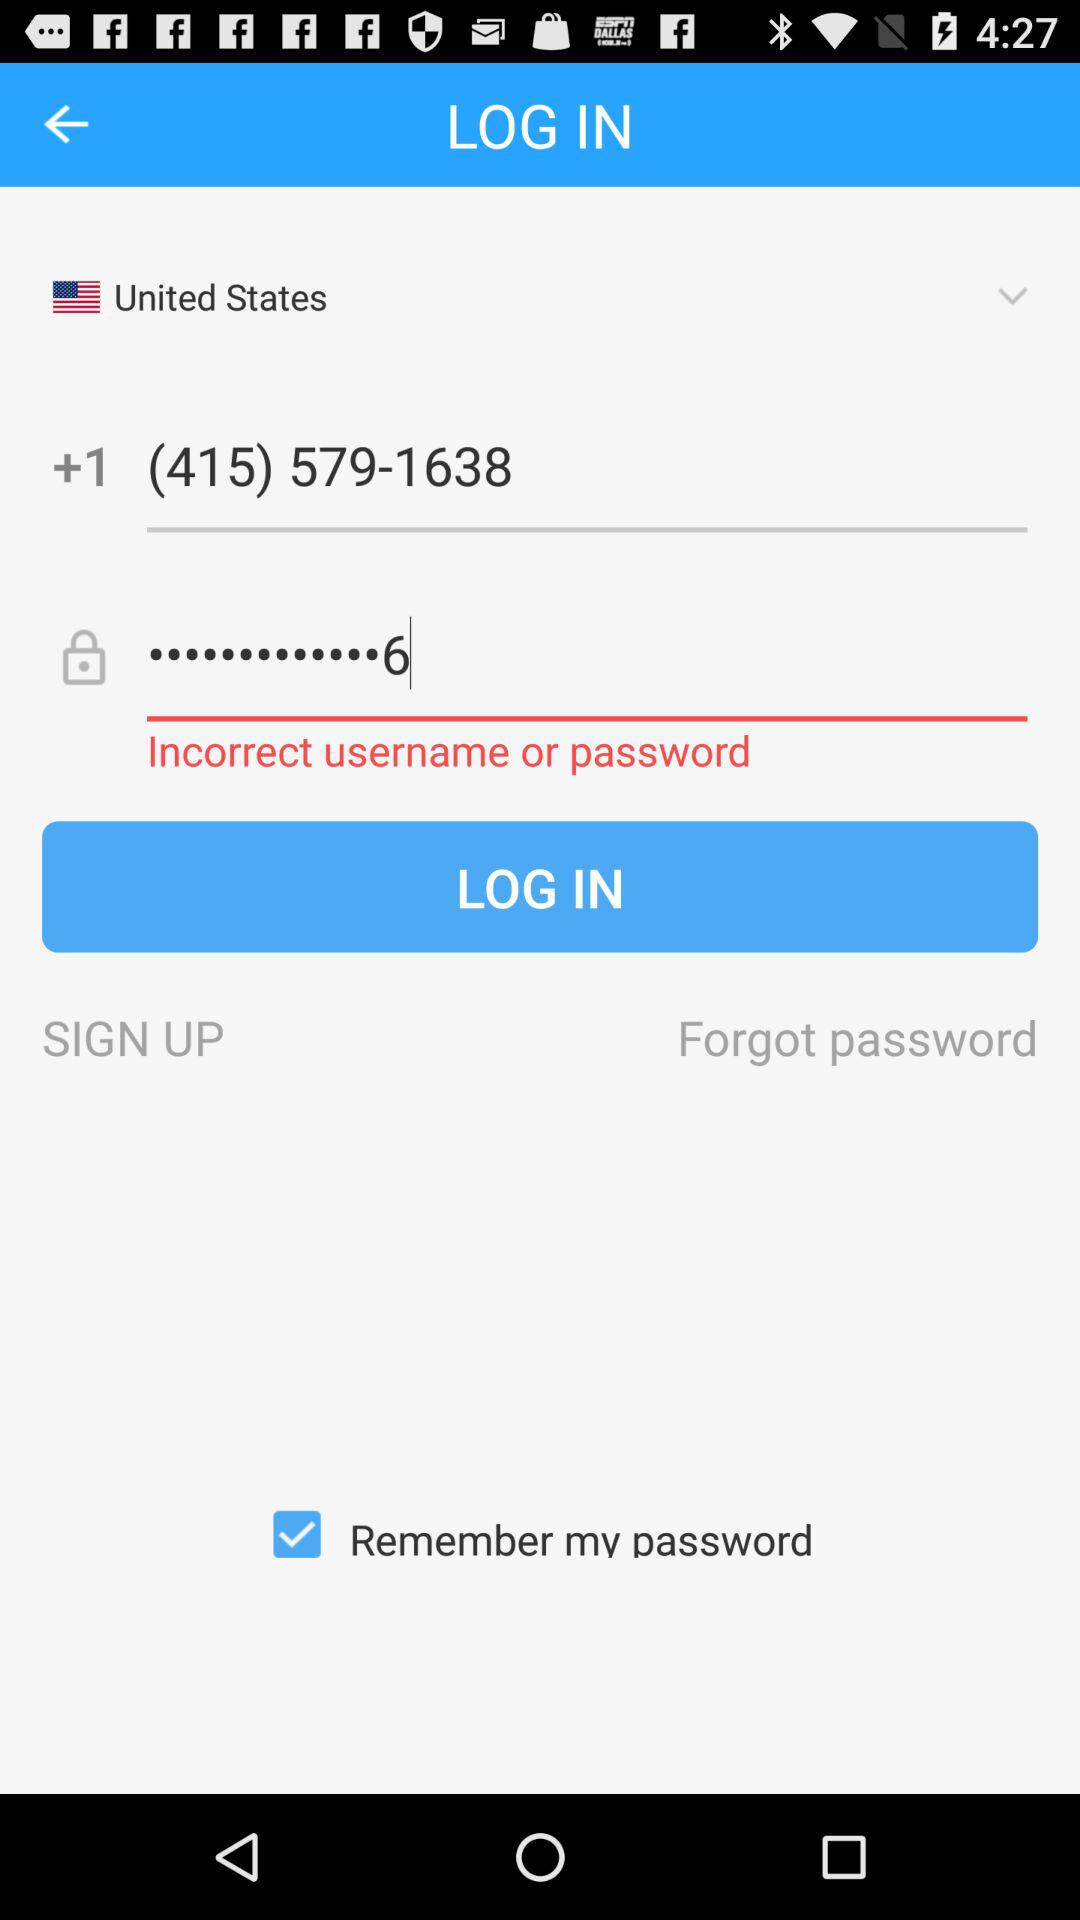Which is the selected country? The selected country is the United States. 